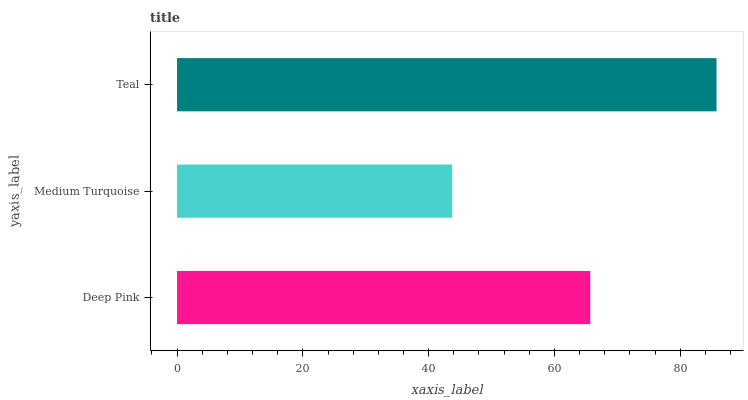Is Medium Turquoise the minimum?
Answer yes or no. Yes. Is Teal the maximum?
Answer yes or no. Yes. Is Teal the minimum?
Answer yes or no. No. Is Medium Turquoise the maximum?
Answer yes or no. No. Is Teal greater than Medium Turquoise?
Answer yes or no. Yes. Is Medium Turquoise less than Teal?
Answer yes or no. Yes. Is Medium Turquoise greater than Teal?
Answer yes or no. No. Is Teal less than Medium Turquoise?
Answer yes or no. No. Is Deep Pink the high median?
Answer yes or no. Yes. Is Deep Pink the low median?
Answer yes or no. Yes. Is Medium Turquoise the high median?
Answer yes or no. No. Is Teal the low median?
Answer yes or no. No. 